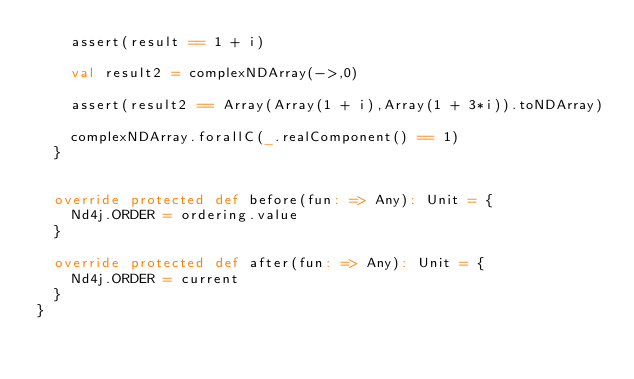Convert code to text. <code><loc_0><loc_0><loc_500><loc_500><_Scala_>    assert(result == 1 + i)

    val result2 = complexNDArray(->,0)

    assert(result2 == Array(Array(1 + i),Array(1 + 3*i)).toNDArray)

    complexNDArray.forallC(_.realComponent() == 1)
  }


  override protected def before(fun: => Any): Unit = {
    Nd4j.ORDER = ordering.value
  }

  override protected def after(fun: => Any): Unit = {
    Nd4j.ORDER = current
  }
}
</code> 